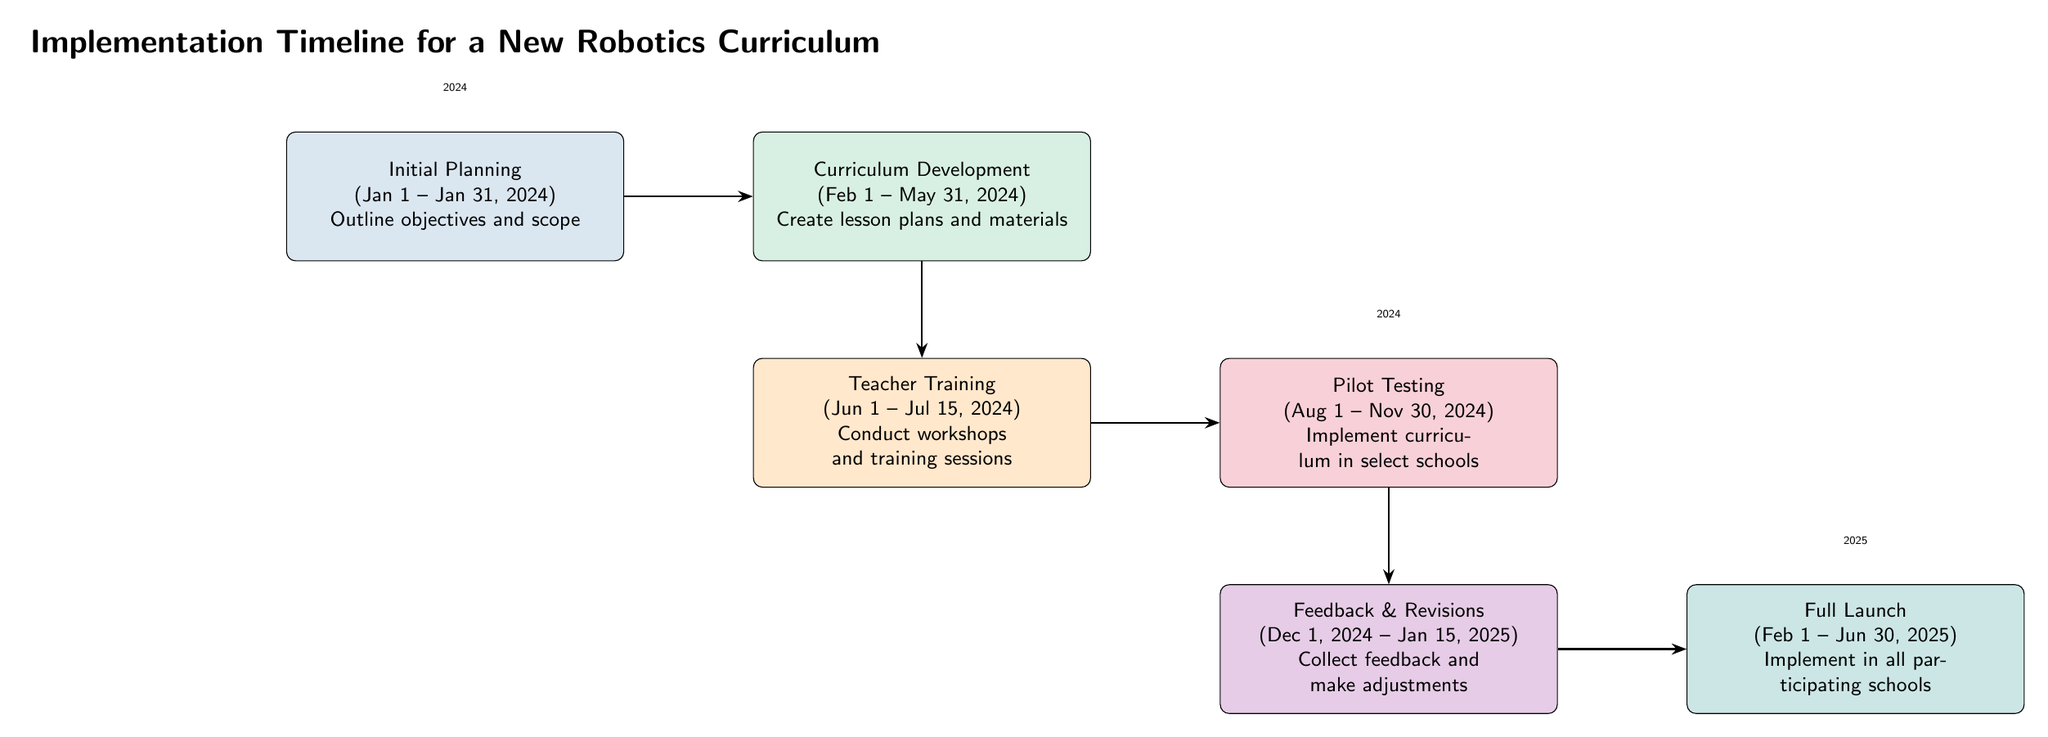What is the duration of the Teacher Training phase? The diagram indicates that the Teacher Training phase runs from June 1 to July 15, 2024. By counting the days between these dates, we find the duration is approximately 1.5 months.
Answer: 1.5 months How many key milestones are there in total? The diagram lists six milestones: Initial Planning, Curriculum Development, Teacher Training, Pilot Testing, Feedback & Revisions, and Full Launch. This total count leads to the answer.
Answer: 6 What is the starting date of the Full Launch? The Full Launch milestone begins on February 1, 2025, according to the timeline given in the diagram.
Answer: February 1, 2025 Which milestone directly follows Pilot Testing? From the timeline flow, after Pilot Testing, the next milestone is Feedback & Revisions. This relationship between the nodes shows the correct flow of the curriculum implementation.
Answer: Feedback & Revisions What color represents Curriculum Development? The Curriculum Development milestone is filled with a custom green shade, as indicated by the color coding in the diagram.
Answer: Custom green What are the objectives outlined in the Initial Planning phase? The Initial Planning phase aims to outline objectives and scope, as explicitly stated in the description of that milestone in the diagram.
Answer: Outline objectives and scope How long does the Pilot Testing phase last? The Pilot Testing milestone starts on August 1 and ends on November 30, 2024. Counting the weeks between these two dates shows that the phase lasts for approximately 4 months.
Answer: 4 months Which phase comes right before the Full Launch? The phase that comes immediately before the Full Launch is Feedback & Revisions, which is shown directly prior in the flow of milestones in the diagram.
Answer: Feedback & Revisions 